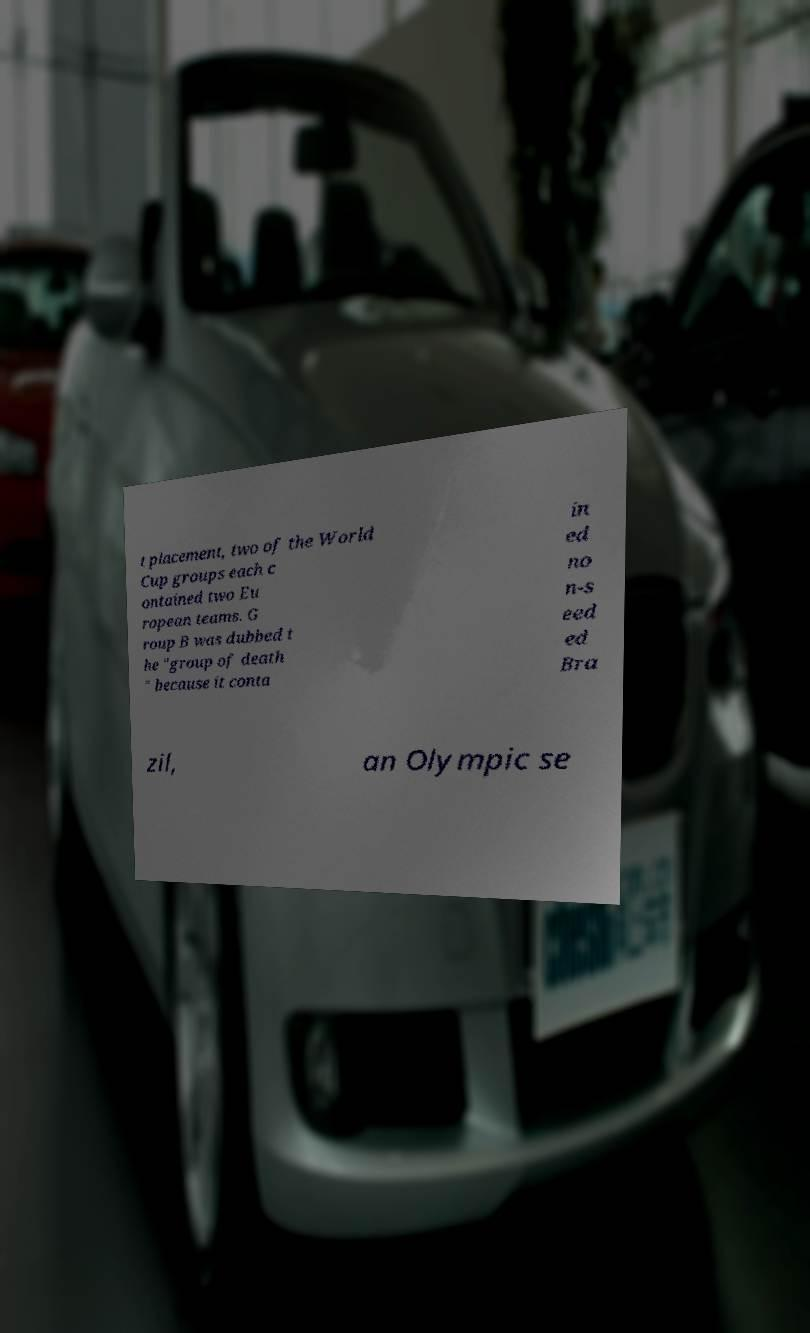Please read and relay the text visible in this image. What does it say? t placement, two of the World Cup groups each c ontained two Eu ropean teams. G roup B was dubbed t he "group of death " because it conta in ed no n-s eed ed Bra zil, an Olympic se 